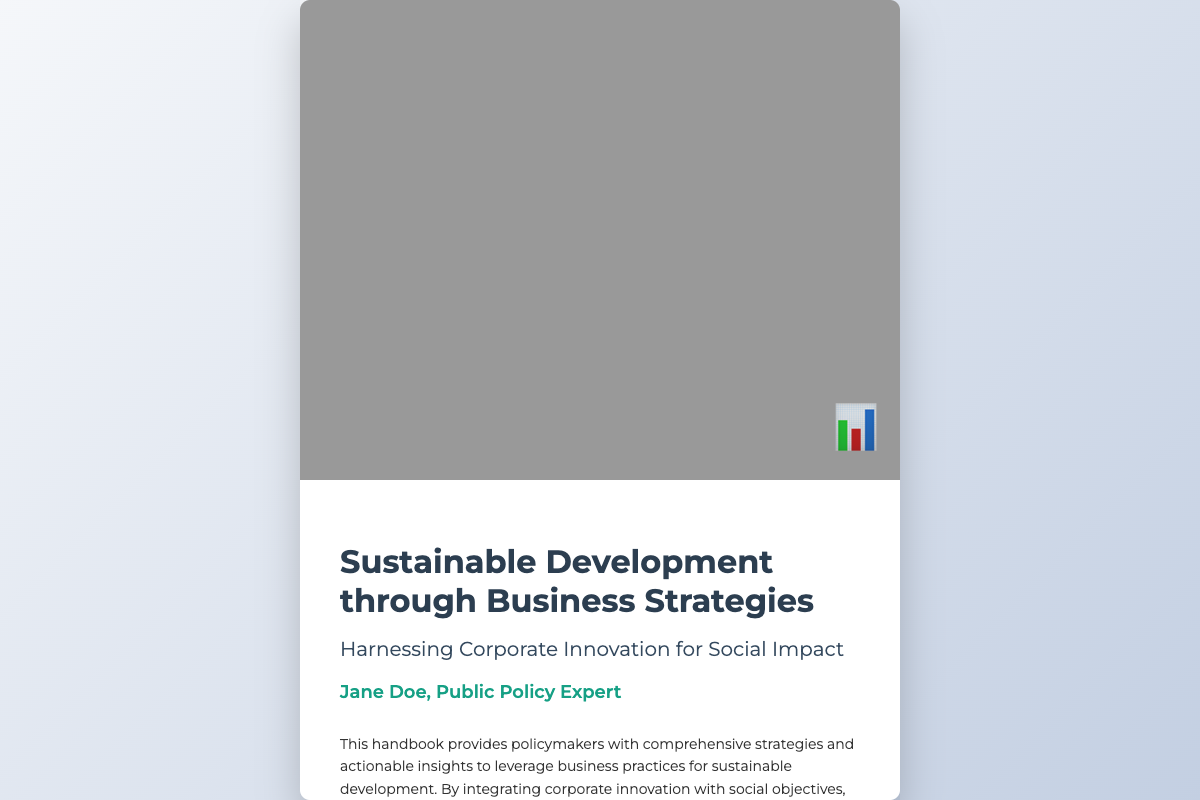What is the title of the book? The title of the book is prominently displayed at the top of the cover.
Answer: Sustainable Development through Business Strategies Who is the author of the book? The author's name is listed below the title on the cover.
Answer: Jane Doe What is the subtitle of the book? The subtitle is listed directly under the title and describes the book's focus.
Answer: Harnessing Corporate Innovation for Social Impact What kind of strategies does the handbook provide? The description mentions specific types of strategies offered in the handbook.
Answer: Comprehensive strategies What is the primary audience for this handbook? The introduction describes who the intended users of the handbook are.
Answer: Policymakers What is the main benefit of integrating corporate innovation according to the description? The description highlights the outcomes of integrating corporate innovation with social objectives.
Answer: Long-term economic, environmental, and social benefits What does the policy icon represent? The icon displayed suggests a theme relevant to the book's content.
Answer: Policy analysis What color is the call-to-action button? The call-to-action button's color is part of the visual design of the cover.
Answer: Blue Where can readers explore more about the handbook? The call-to-action invites readers to take a specific action regarding the handbook.
Answer: Explore the Handbook 